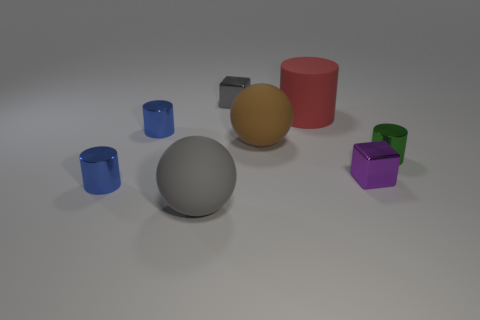There is a cube to the right of the large red matte object; what is its size?
Your response must be concise. Small. What is the shape of the gray thing behind the tiny shiny cylinder on the right side of the gray rubber ball?
Your answer should be very brief. Cube. There is another large object that is the same shape as the green object; what is its color?
Give a very brief answer. Red. There is a gray thing in front of the brown ball; is its size the same as the brown rubber object?
Your answer should be very brief. Yes. What number of tiny gray things have the same material as the green cylinder?
Your response must be concise. 1. What material is the gray thing that is on the right side of the big matte sphere that is in front of the metal cube to the right of the red cylinder?
Ensure brevity in your answer.  Metal. What is the color of the large thing in front of the small metallic cube that is in front of the large rubber cylinder?
Provide a short and direct response. Gray. What is the color of the metallic block that is the same size as the purple thing?
Keep it short and to the point. Gray. How many big things are rubber spheres or green objects?
Provide a succinct answer. 2. Is the number of gray matte balls that are right of the small green cylinder greater than the number of small cylinders in front of the large brown matte ball?
Your response must be concise. No. 